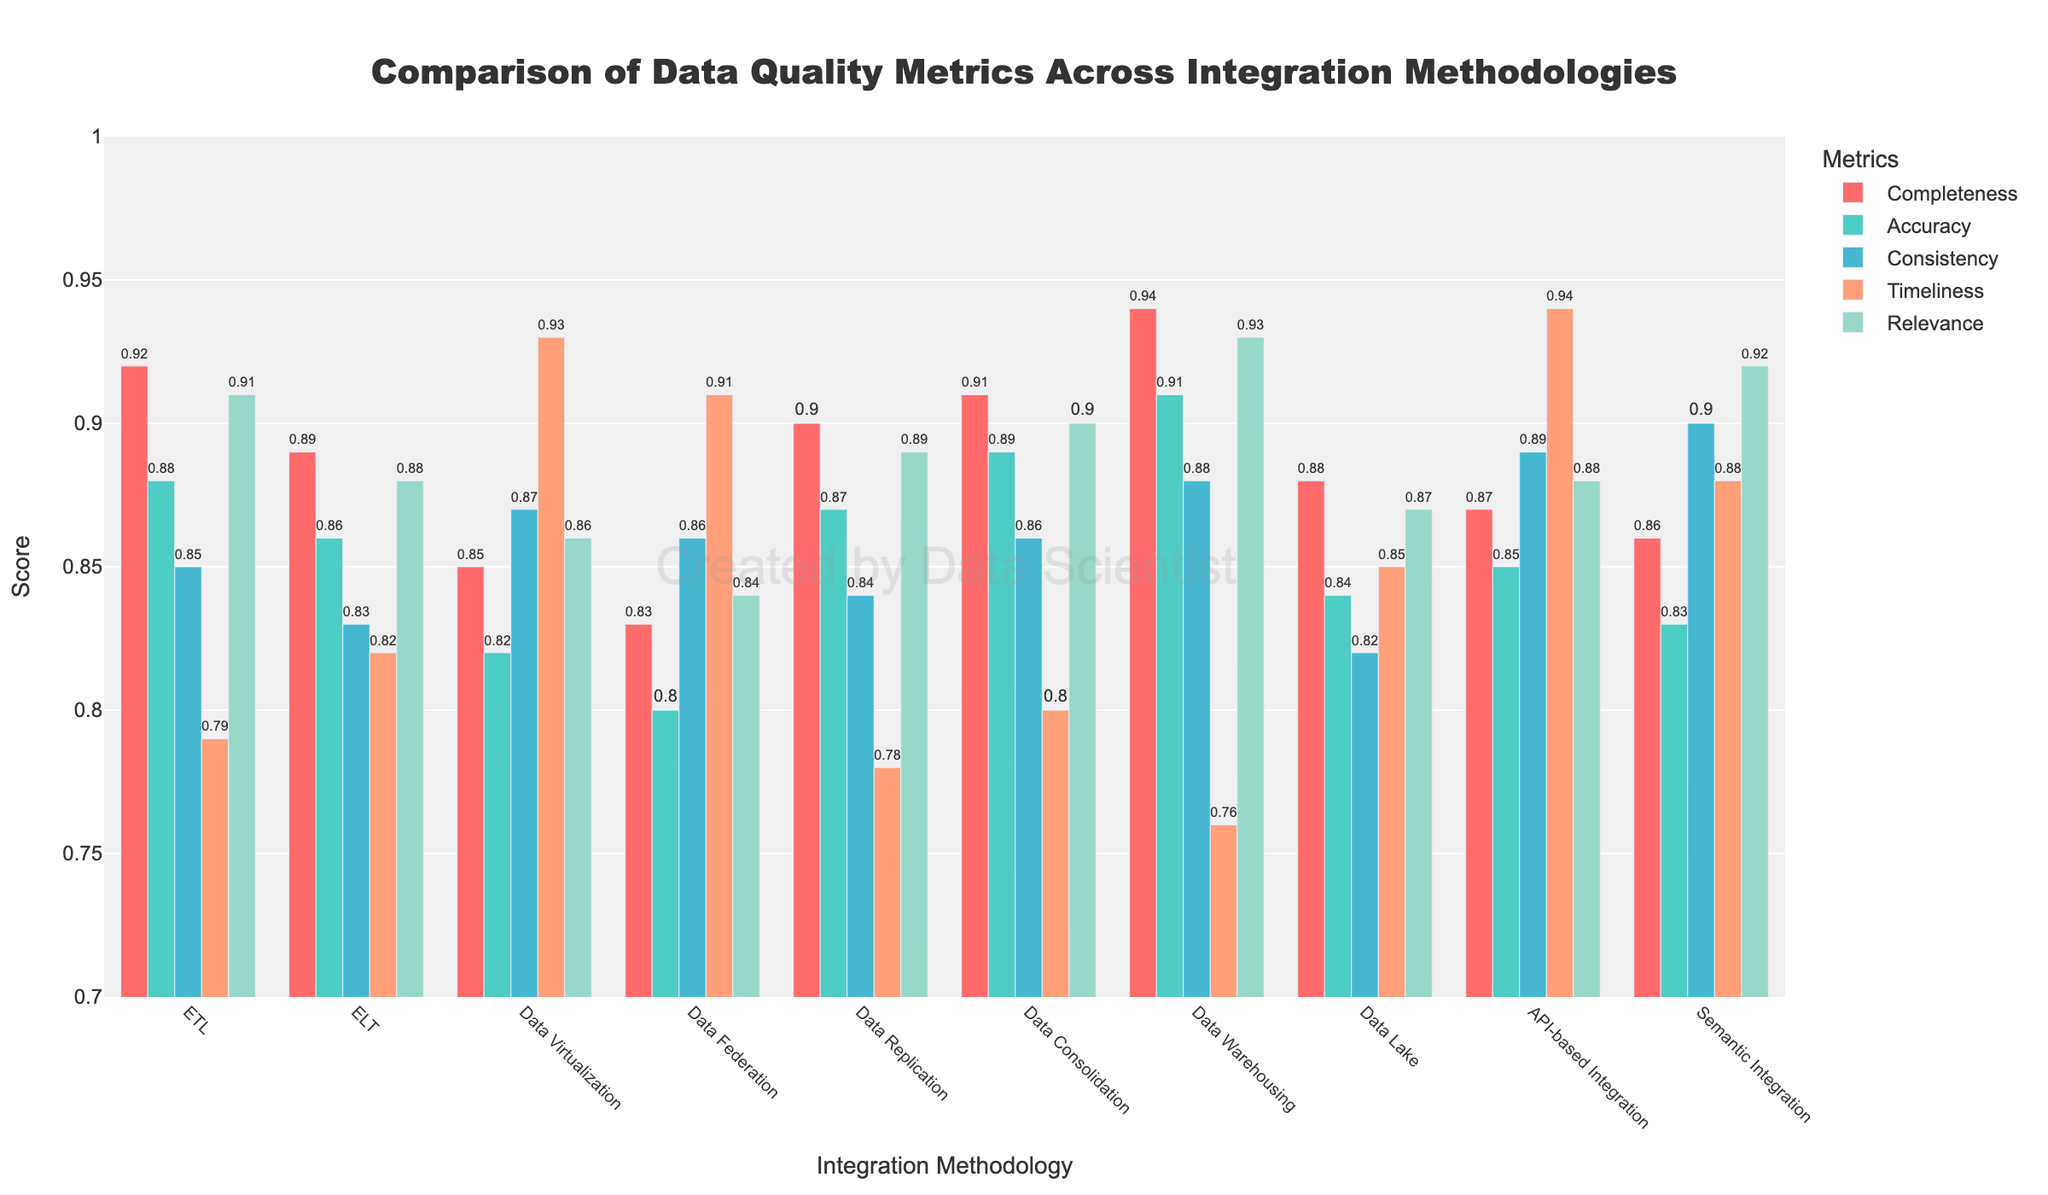Which methodology has the highest Completeness score? The Completeness scores for all methodologies are compared. Data Warehousing has the highest score at 0.94.
Answer: Data Warehousing What is the difference in Accuracy score between ETL and Data Federation? ETL has an Accuracy score of 0.88 while Data Federation has a score of 0.80. The difference is calculated as 0.88 - 0.80 = 0.08.
Answer: 0.08 Which methodology shows the highest Consistency score? The Consistency scores for all methodologies are compared. API-based Integration has the highest score at 0.89.
Answer: API-based Integration Among Data Virtualization, Data Replication, and Data Lake, which one has the highest Timeliness score? The Timeliness scores for Data Virtualization, Data Replication, and Data Lake are 0.93, 0.78, and 0.85 respectively. Data Virtualization has the highest score.
Answer: Data Virtualization What is the average Relevance score for ETL, ELT, and Semantic Integration? The Relevance scores for ETL, ELT, and Semantic Integration are 0.91, 0.88, and 0.92 respectively. The average is calculated as (0.91 + 0.88 + 0.92) / 3 ≈ 0.903.
Answer: 0.90 Which metric has the lowest score for Data Lake methodology and what is its value? The scores for Data Lake are evaluated across all metrics. The lowest score is 0.82 for Consistency.
Answer: Consistency, 0.82 Which two methodologies show the closest Completeness score, and what is the score? The Completeness scores for all methodologies are compared. Data Replication (0.90) and Data Lake (0.88) are the closest.
Answer: Data Replication, Data Lake (0.90) In terms of Accuracy, is there any methodology scoring exactly 0.85? All methodologies are checked for Accuracy scores. Both ETL (0.88) and ELT (0.86) do not match 0.85, but API-based Integration does.
Answer: Yes, API-based Integration For which metric does Data Warehousing show the lowest score, and what is its value? The scores for Data Warehousing are compared across all metrics. The lowest score is for Timeliness at 0.76.
Answer: Timeliness, 0.76 